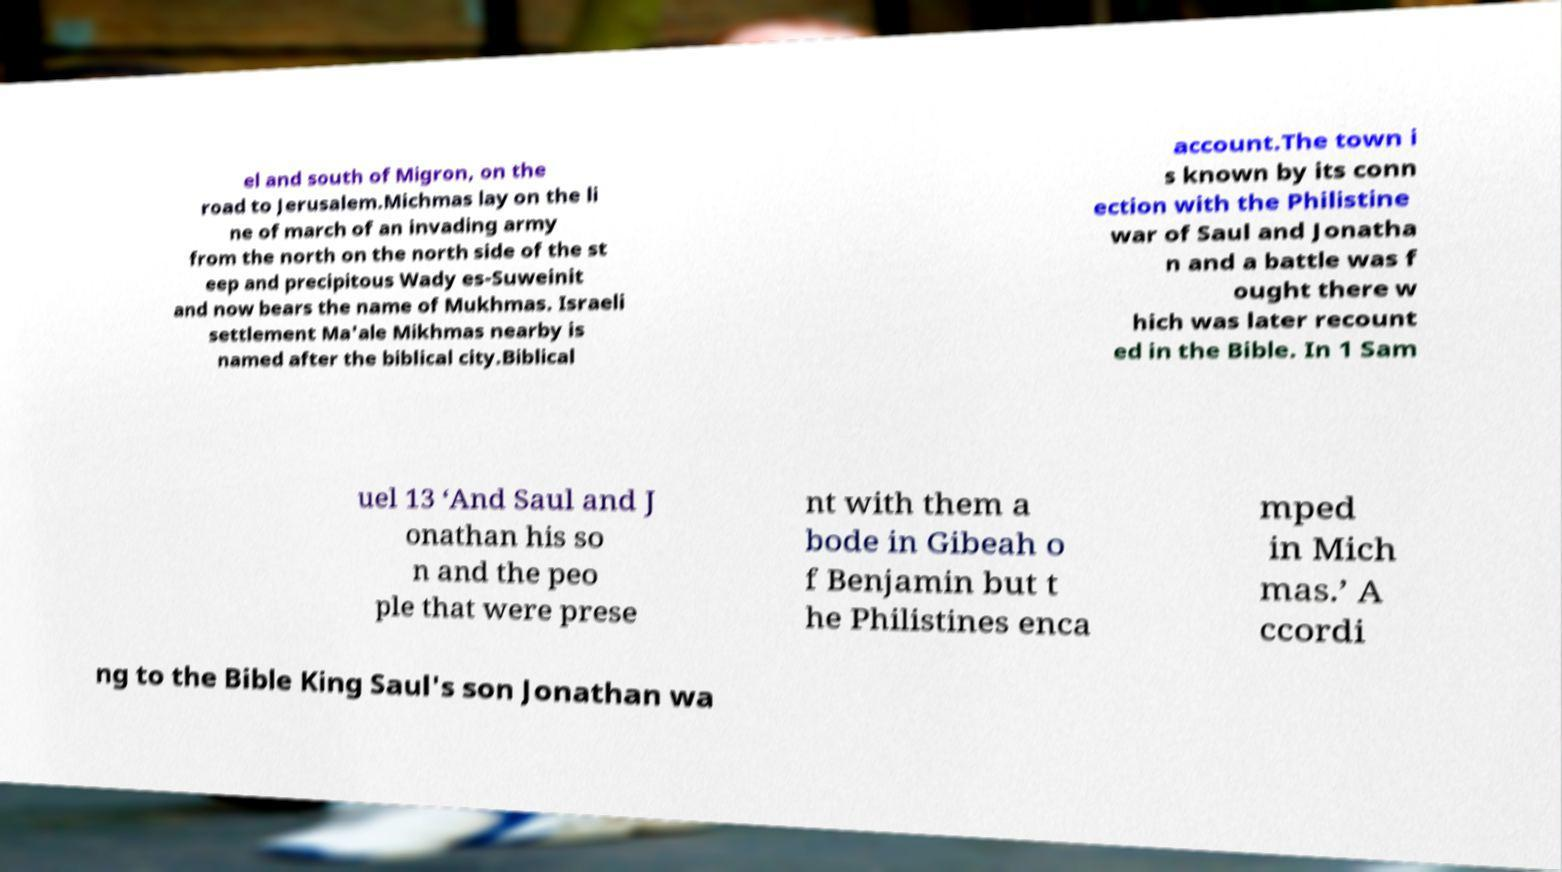Can you accurately transcribe the text from the provided image for me? el and south of Migron, on the road to Jerusalem.Michmas lay on the li ne of march of an invading army from the north on the north side of the st eep and precipitous Wady es-Suweinit and now bears the name of Mukhmas. Israeli settlement Ma'ale Mikhmas nearby is named after the biblical city.Biblical account.The town i s known by its conn ection with the Philistine war of Saul and Jonatha n and a battle was f ought there w hich was later recount ed in the Bible. In 1 Sam uel 13 ‘And Saul and J onathan his so n and the peo ple that were prese nt with them a bode in Gibeah o f Benjamin but t he Philistines enca mped in Mich mas.’ A ccordi ng to the Bible King Saul's son Jonathan wa 